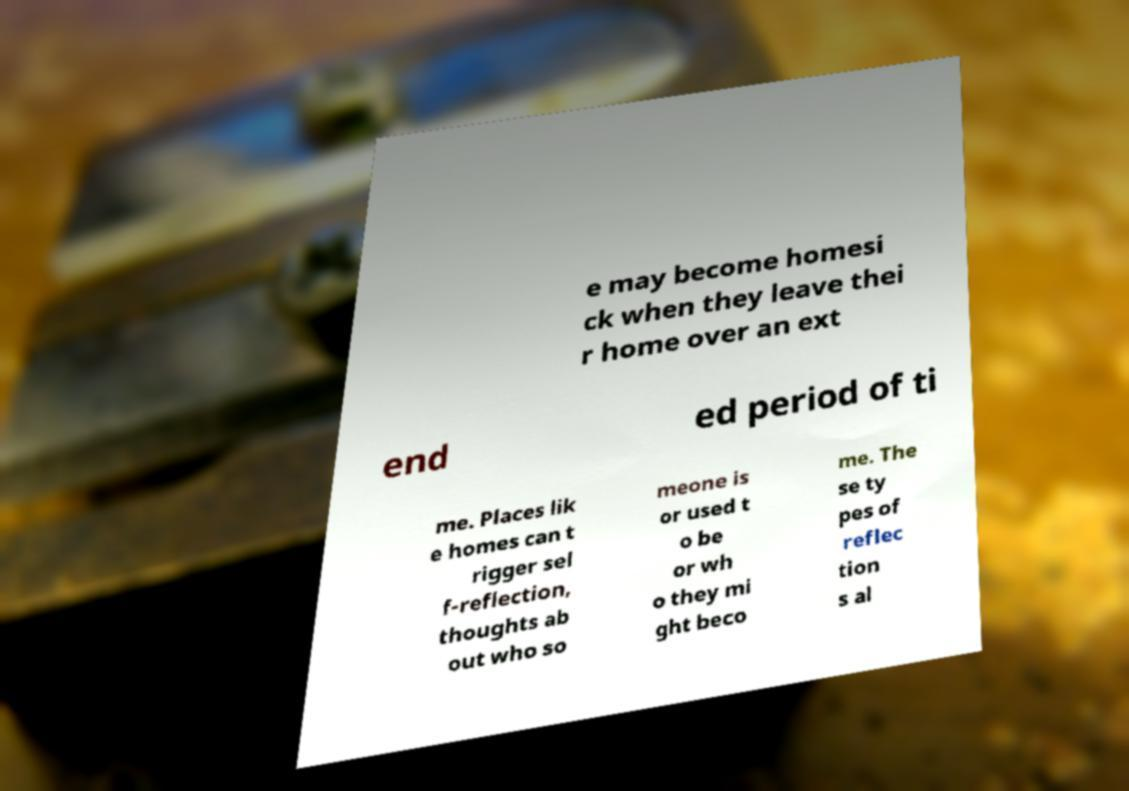What messages or text are displayed in this image? I need them in a readable, typed format. e may become homesi ck when they leave thei r home over an ext end ed period of ti me. Places lik e homes can t rigger sel f-reflection, thoughts ab out who so meone is or used t o be or wh o they mi ght beco me. The se ty pes of reflec tion s al 